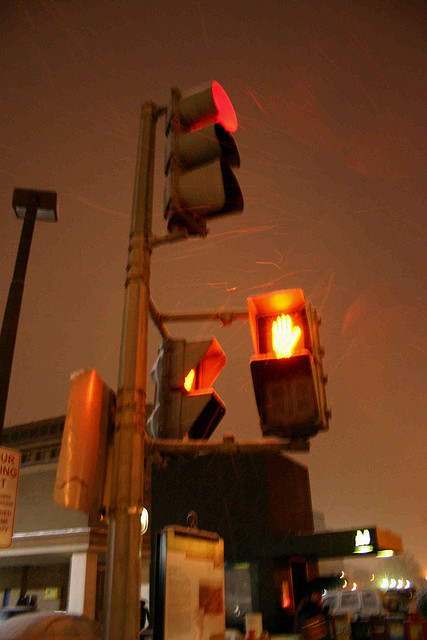Are there lights on in the picture? Yes, there are several lights on in the image, including traffic signals displaying 'stop' and 'don't walk' indicators as well as street lights contributing to the ambient lighting of the scene. 